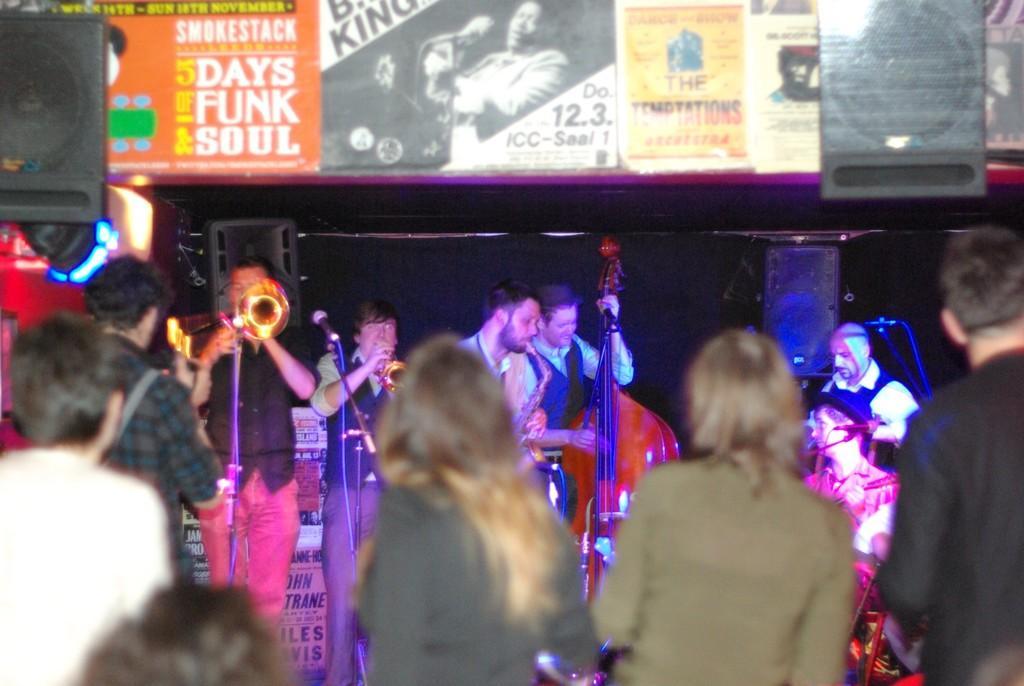Can you describe this image briefly? In the image I can see group of people are standing among them the people in the background are holding musical instruments in hands. I can also see microphones, boards which has something written on them and photos of people. I can also see sound speakers and some other objects. 